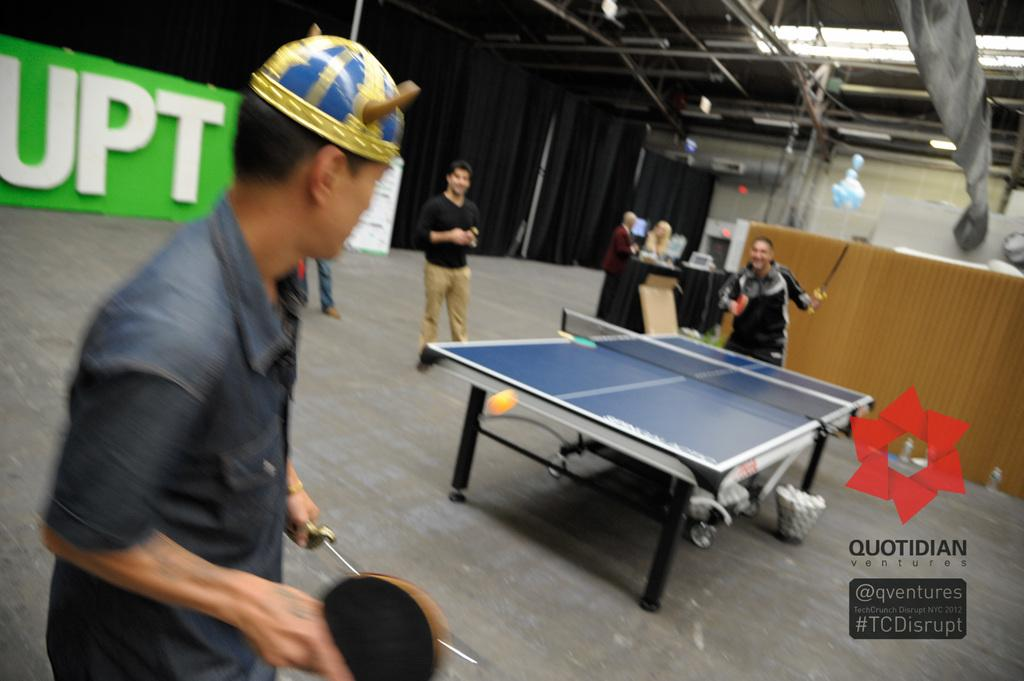What activity are the two people in the image engaged in? The two people in the image are playing table tennis. Can you describe the lighting in the image? There is a light at the top in the image. What type of substance is falling from the sky during the rainstorm in the image? There is no rainstorm present in the image, so it is not possible to determine what type of substance might be falling from the sky. 